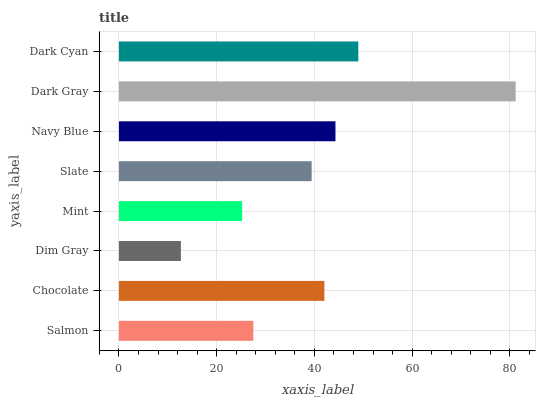Is Dim Gray the minimum?
Answer yes or no. Yes. Is Dark Gray the maximum?
Answer yes or no. Yes. Is Chocolate the minimum?
Answer yes or no. No. Is Chocolate the maximum?
Answer yes or no. No. Is Chocolate greater than Salmon?
Answer yes or no. Yes. Is Salmon less than Chocolate?
Answer yes or no. Yes. Is Salmon greater than Chocolate?
Answer yes or no. No. Is Chocolate less than Salmon?
Answer yes or no. No. Is Chocolate the high median?
Answer yes or no. Yes. Is Slate the low median?
Answer yes or no. Yes. Is Dim Gray the high median?
Answer yes or no. No. Is Salmon the low median?
Answer yes or no. No. 